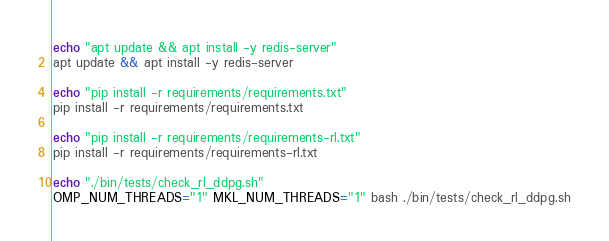Convert code to text. <code><loc_0><loc_0><loc_500><loc_500><_Bash_>echo "apt update && apt install -y redis-server"
apt update && apt install -y redis-server

echo "pip install -r requirements/requirements.txt"
pip install -r requirements/requirements.txt

echo "pip install -r requirements/requirements-rl.txt"
pip install -r requirements/requirements-rl.txt

echo "./bin/tests/check_rl_ddpg.sh"
OMP_NUM_THREADS="1" MKL_NUM_THREADS="1" bash ./bin/tests/check_rl_ddpg.sh</code> 